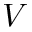Convert formula to latex. <formula><loc_0><loc_0><loc_500><loc_500>V</formula> 